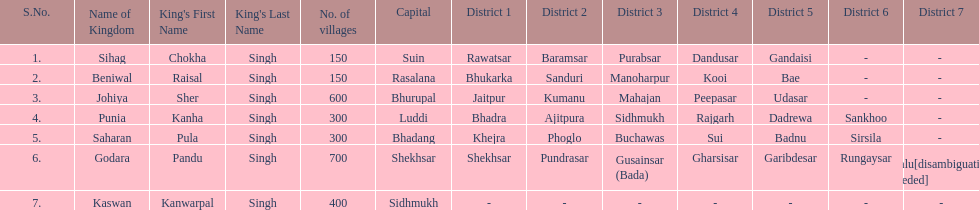Does punia have more or less villages than godara? Less. 